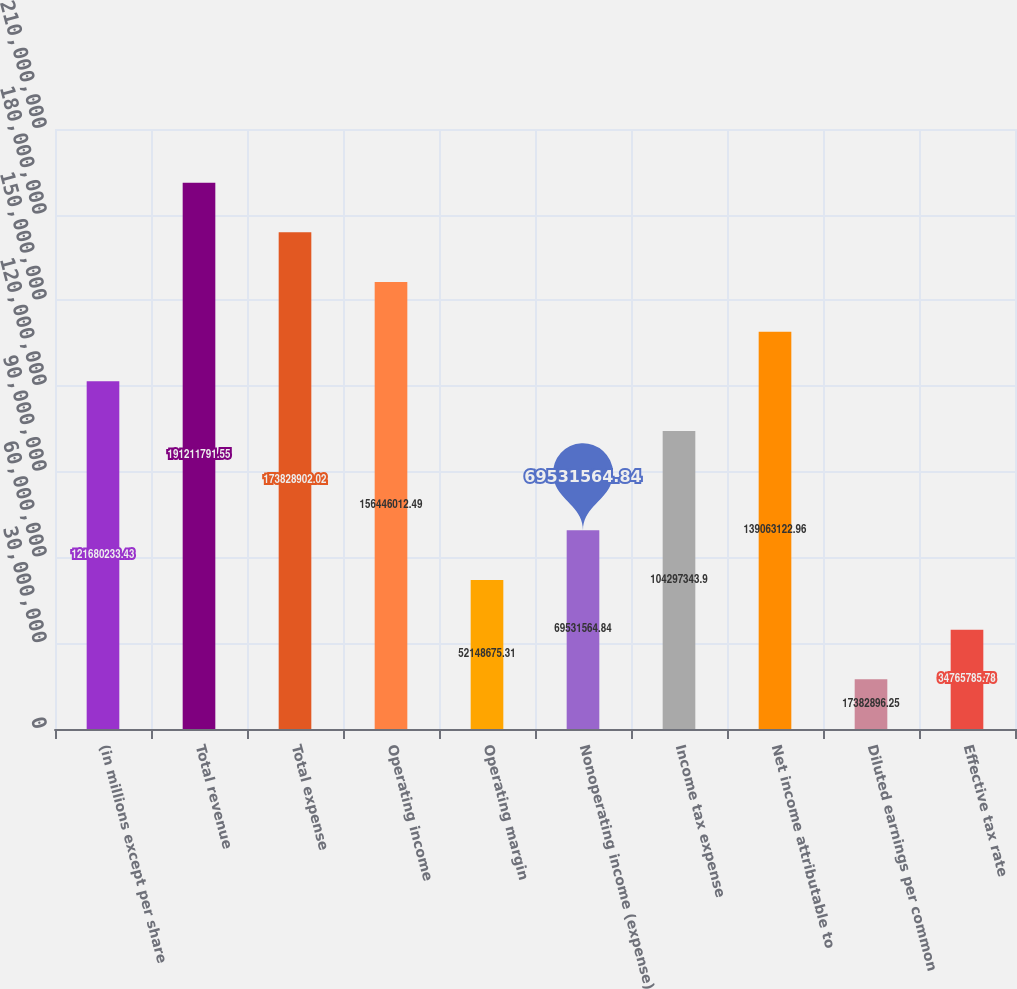Convert chart. <chart><loc_0><loc_0><loc_500><loc_500><bar_chart><fcel>(in millions except per share<fcel>Total revenue<fcel>Total expense<fcel>Operating income<fcel>Operating margin<fcel>Nonoperating income (expense)<fcel>Income tax expense<fcel>Net income attributable to<fcel>Diluted earnings per common<fcel>Effective tax rate<nl><fcel>1.2168e+08<fcel>1.91212e+08<fcel>1.73829e+08<fcel>1.56446e+08<fcel>5.21487e+07<fcel>6.95316e+07<fcel>1.04297e+08<fcel>1.39063e+08<fcel>1.73829e+07<fcel>3.47658e+07<nl></chart> 